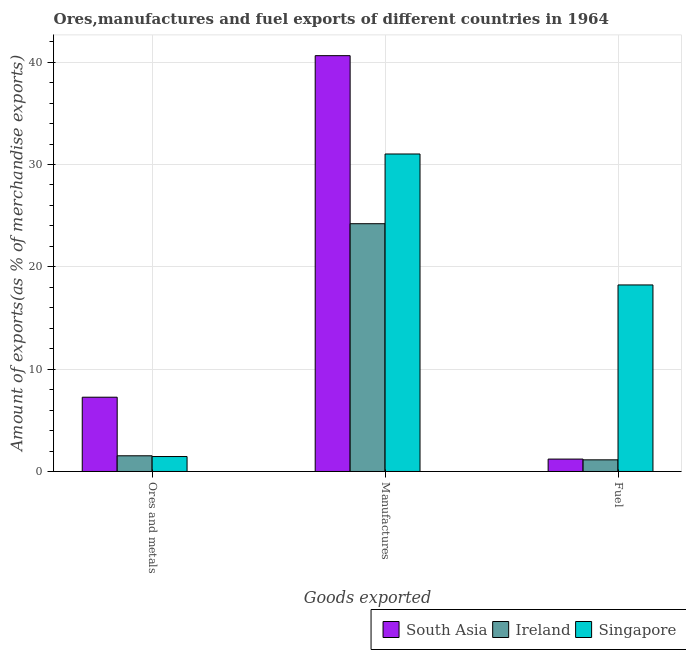How many different coloured bars are there?
Ensure brevity in your answer.  3. How many groups of bars are there?
Provide a short and direct response. 3. How many bars are there on the 1st tick from the left?
Give a very brief answer. 3. What is the label of the 1st group of bars from the left?
Make the answer very short. Ores and metals. What is the percentage of fuel exports in Singapore?
Offer a terse response. 18.23. Across all countries, what is the maximum percentage of ores and metals exports?
Offer a terse response. 7.26. Across all countries, what is the minimum percentage of ores and metals exports?
Your answer should be compact. 1.46. In which country was the percentage of fuel exports maximum?
Your answer should be compact. Singapore. In which country was the percentage of ores and metals exports minimum?
Keep it short and to the point. Singapore. What is the total percentage of ores and metals exports in the graph?
Your answer should be very brief. 10.25. What is the difference between the percentage of manufactures exports in Singapore and that in South Asia?
Offer a terse response. -9.61. What is the difference between the percentage of fuel exports in South Asia and the percentage of manufactures exports in Singapore?
Provide a succinct answer. -29.82. What is the average percentage of ores and metals exports per country?
Your response must be concise. 3.42. What is the difference between the percentage of manufactures exports and percentage of fuel exports in Singapore?
Provide a short and direct response. 12.8. What is the ratio of the percentage of manufactures exports in South Asia to that in Singapore?
Offer a terse response. 1.31. Is the percentage of manufactures exports in Singapore less than that in South Asia?
Provide a short and direct response. Yes. Is the difference between the percentage of fuel exports in South Asia and Singapore greater than the difference between the percentage of manufactures exports in South Asia and Singapore?
Keep it short and to the point. No. What is the difference between the highest and the second highest percentage of manufactures exports?
Your answer should be very brief. 9.61. What is the difference between the highest and the lowest percentage of fuel exports?
Provide a succinct answer. 17.09. What does the 1st bar from the left in Manufactures represents?
Offer a terse response. South Asia. What does the 2nd bar from the right in Manufactures represents?
Give a very brief answer. Ireland. What is the difference between two consecutive major ticks on the Y-axis?
Keep it short and to the point. 10. Does the graph contain any zero values?
Make the answer very short. No. Does the graph contain grids?
Provide a succinct answer. Yes. How many legend labels are there?
Ensure brevity in your answer.  3. How are the legend labels stacked?
Your answer should be very brief. Horizontal. What is the title of the graph?
Your response must be concise. Ores,manufactures and fuel exports of different countries in 1964. Does "Isle of Man" appear as one of the legend labels in the graph?
Your answer should be very brief. No. What is the label or title of the X-axis?
Provide a short and direct response. Goods exported. What is the label or title of the Y-axis?
Provide a short and direct response. Amount of exports(as % of merchandise exports). What is the Amount of exports(as % of merchandise exports) of South Asia in Ores and metals?
Make the answer very short. 7.26. What is the Amount of exports(as % of merchandise exports) in Ireland in Ores and metals?
Make the answer very short. 1.53. What is the Amount of exports(as % of merchandise exports) in Singapore in Ores and metals?
Offer a very short reply. 1.46. What is the Amount of exports(as % of merchandise exports) in South Asia in Manufactures?
Your response must be concise. 40.64. What is the Amount of exports(as % of merchandise exports) of Ireland in Manufactures?
Your answer should be compact. 24.22. What is the Amount of exports(as % of merchandise exports) of Singapore in Manufactures?
Your answer should be very brief. 31.03. What is the Amount of exports(as % of merchandise exports) in South Asia in Fuel?
Keep it short and to the point. 1.21. What is the Amount of exports(as % of merchandise exports) of Ireland in Fuel?
Your answer should be very brief. 1.14. What is the Amount of exports(as % of merchandise exports) of Singapore in Fuel?
Keep it short and to the point. 18.23. Across all Goods exported, what is the maximum Amount of exports(as % of merchandise exports) of South Asia?
Ensure brevity in your answer.  40.64. Across all Goods exported, what is the maximum Amount of exports(as % of merchandise exports) of Ireland?
Make the answer very short. 24.22. Across all Goods exported, what is the maximum Amount of exports(as % of merchandise exports) of Singapore?
Your answer should be compact. 31.03. Across all Goods exported, what is the minimum Amount of exports(as % of merchandise exports) in South Asia?
Your answer should be very brief. 1.21. Across all Goods exported, what is the minimum Amount of exports(as % of merchandise exports) in Ireland?
Provide a short and direct response. 1.14. Across all Goods exported, what is the minimum Amount of exports(as % of merchandise exports) in Singapore?
Your answer should be very brief. 1.46. What is the total Amount of exports(as % of merchandise exports) of South Asia in the graph?
Your answer should be compact. 49.11. What is the total Amount of exports(as % of merchandise exports) in Ireland in the graph?
Offer a very short reply. 26.89. What is the total Amount of exports(as % of merchandise exports) in Singapore in the graph?
Provide a short and direct response. 50.72. What is the difference between the Amount of exports(as % of merchandise exports) in South Asia in Ores and metals and that in Manufactures?
Provide a succinct answer. -33.38. What is the difference between the Amount of exports(as % of merchandise exports) in Ireland in Ores and metals and that in Manufactures?
Provide a short and direct response. -22.68. What is the difference between the Amount of exports(as % of merchandise exports) in Singapore in Ores and metals and that in Manufactures?
Your response must be concise. -29.57. What is the difference between the Amount of exports(as % of merchandise exports) of South Asia in Ores and metals and that in Fuel?
Provide a succinct answer. 6.05. What is the difference between the Amount of exports(as % of merchandise exports) in Ireland in Ores and metals and that in Fuel?
Your response must be concise. 0.4. What is the difference between the Amount of exports(as % of merchandise exports) of Singapore in Ores and metals and that in Fuel?
Offer a very short reply. -16.77. What is the difference between the Amount of exports(as % of merchandise exports) in South Asia in Manufactures and that in Fuel?
Give a very brief answer. 39.43. What is the difference between the Amount of exports(as % of merchandise exports) of Ireland in Manufactures and that in Fuel?
Your answer should be compact. 23.08. What is the difference between the Amount of exports(as % of merchandise exports) in Singapore in Manufactures and that in Fuel?
Provide a succinct answer. 12.8. What is the difference between the Amount of exports(as % of merchandise exports) of South Asia in Ores and metals and the Amount of exports(as % of merchandise exports) of Ireland in Manufactures?
Keep it short and to the point. -16.96. What is the difference between the Amount of exports(as % of merchandise exports) of South Asia in Ores and metals and the Amount of exports(as % of merchandise exports) of Singapore in Manufactures?
Keep it short and to the point. -23.77. What is the difference between the Amount of exports(as % of merchandise exports) of Ireland in Ores and metals and the Amount of exports(as % of merchandise exports) of Singapore in Manufactures?
Ensure brevity in your answer.  -29.5. What is the difference between the Amount of exports(as % of merchandise exports) of South Asia in Ores and metals and the Amount of exports(as % of merchandise exports) of Ireland in Fuel?
Offer a very short reply. 6.12. What is the difference between the Amount of exports(as % of merchandise exports) of South Asia in Ores and metals and the Amount of exports(as % of merchandise exports) of Singapore in Fuel?
Keep it short and to the point. -10.97. What is the difference between the Amount of exports(as % of merchandise exports) in Ireland in Ores and metals and the Amount of exports(as % of merchandise exports) in Singapore in Fuel?
Offer a terse response. -16.7. What is the difference between the Amount of exports(as % of merchandise exports) in South Asia in Manufactures and the Amount of exports(as % of merchandise exports) in Ireland in Fuel?
Make the answer very short. 39.5. What is the difference between the Amount of exports(as % of merchandise exports) of South Asia in Manufactures and the Amount of exports(as % of merchandise exports) of Singapore in Fuel?
Ensure brevity in your answer.  22.41. What is the difference between the Amount of exports(as % of merchandise exports) in Ireland in Manufactures and the Amount of exports(as % of merchandise exports) in Singapore in Fuel?
Your response must be concise. 5.98. What is the average Amount of exports(as % of merchandise exports) of South Asia per Goods exported?
Provide a short and direct response. 16.37. What is the average Amount of exports(as % of merchandise exports) of Ireland per Goods exported?
Your answer should be very brief. 8.96. What is the average Amount of exports(as % of merchandise exports) in Singapore per Goods exported?
Your answer should be compact. 16.91. What is the difference between the Amount of exports(as % of merchandise exports) of South Asia and Amount of exports(as % of merchandise exports) of Ireland in Ores and metals?
Provide a succinct answer. 5.72. What is the difference between the Amount of exports(as % of merchandise exports) of South Asia and Amount of exports(as % of merchandise exports) of Singapore in Ores and metals?
Provide a succinct answer. 5.8. What is the difference between the Amount of exports(as % of merchandise exports) of Ireland and Amount of exports(as % of merchandise exports) of Singapore in Ores and metals?
Provide a short and direct response. 0.07. What is the difference between the Amount of exports(as % of merchandise exports) of South Asia and Amount of exports(as % of merchandise exports) of Ireland in Manufactures?
Your response must be concise. 16.42. What is the difference between the Amount of exports(as % of merchandise exports) of South Asia and Amount of exports(as % of merchandise exports) of Singapore in Manufactures?
Offer a very short reply. 9.61. What is the difference between the Amount of exports(as % of merchandise exports) in Ireland and Amount of exports(as % of merchandise exports) in Singapore in Manufactures?
Make the answer very short. -6.82. What is the difference between the Amount of exports(as % of merchandise exports) in South Asia and Amount of exports(as % of merchandise exports) in Ireland in Fuel?
Ensure brevity in your answer.  0.07. What is the difference between the Amount of exports(as % of merchandise exports) of South Asia and Amount of exports(as % of merchandise exports) of Singapore in Fuel?
Offer a terse response. -17.02. What is the difference between the Amount of exports(as % of merchandise exports) in Ireland and Amount of exports(as % of merchandise exports) in Singapore in Fuel?
Ensure brevity in your answer.  -17.09. What is the ratio of the Amount of exports(as % of merchandise exports) of South Asia in Ores and metals to that in Manufactures?
Provide a succinct answer. 0.18. What is the ratio of the Amount of exports(as % of merchandise exports) in Ireland in Ores and metals to that in Manufactures?
Offer a very short reply. 0.06. What is the ratio of the Amount of exports(as % of merchandise exports) in Singapore in Ores and metals to that in Manufactures?
Your response must be concise. 0.05. What is the ratio of the Amount of exports(as % of merchandise exports) in South Asia in Ores and metals to that in Fuel?
Offer a very short reply. 5.99. What is the ratio of the Amount of exports(as % of merchandise exports) in Ireland in Ores and metals to that in Fuel?
Ensure brevity in your answer.  1.35. What is the ratio of the Amount of exports(as % of merchandise exports) in Singapore in Ores and metals to that in Fuel?
Provide a succinct answer. 0.08. What is the ratio of the Amount of exports(as % of merchandise exports) in South Asia in Manufactures to that in Fuel?
Keep it short and to the point. 33.53. What is the ratio of the Amount of exports(as % of merchandise exports) of Ireland in Manufactures to that in Fuel?
Give a very brief answer. 21.28. What is the ratio of the Amount of exports(as % of merchandise exports) in Singapore in Manufactures to that in Fuel?
Your response must be concise. 1.7. What is the difference between the highest and the second highest Amount of exports(as % of merchandise exports) in South Asia?
Your response must be concise. 33.38. What is the difference between the highest and the second highest Amount of exports(as % of merchandise exports) in Ireland?
Ensure brevity in your answer.  22.68. What is the difference between the highest and the second highest Amount of exports(as % of merchandise exports) of Singapore?
Your response must be concise. 12.8. What is the difference between the highest and the lowest Amount of exports(as % of merchandise exports) of South Asia?
Provide a succinct answer. 39.43. What is the difference between the highest and the lowest Amount of exports(as % of merchandise exports) of Ireland?
Your response must be concise. 23.08. What is the difference between the highest and the lowest Amount of exports(as % of merchandise exports) of Singapore?
Your answer should be very brief. 29.57. 